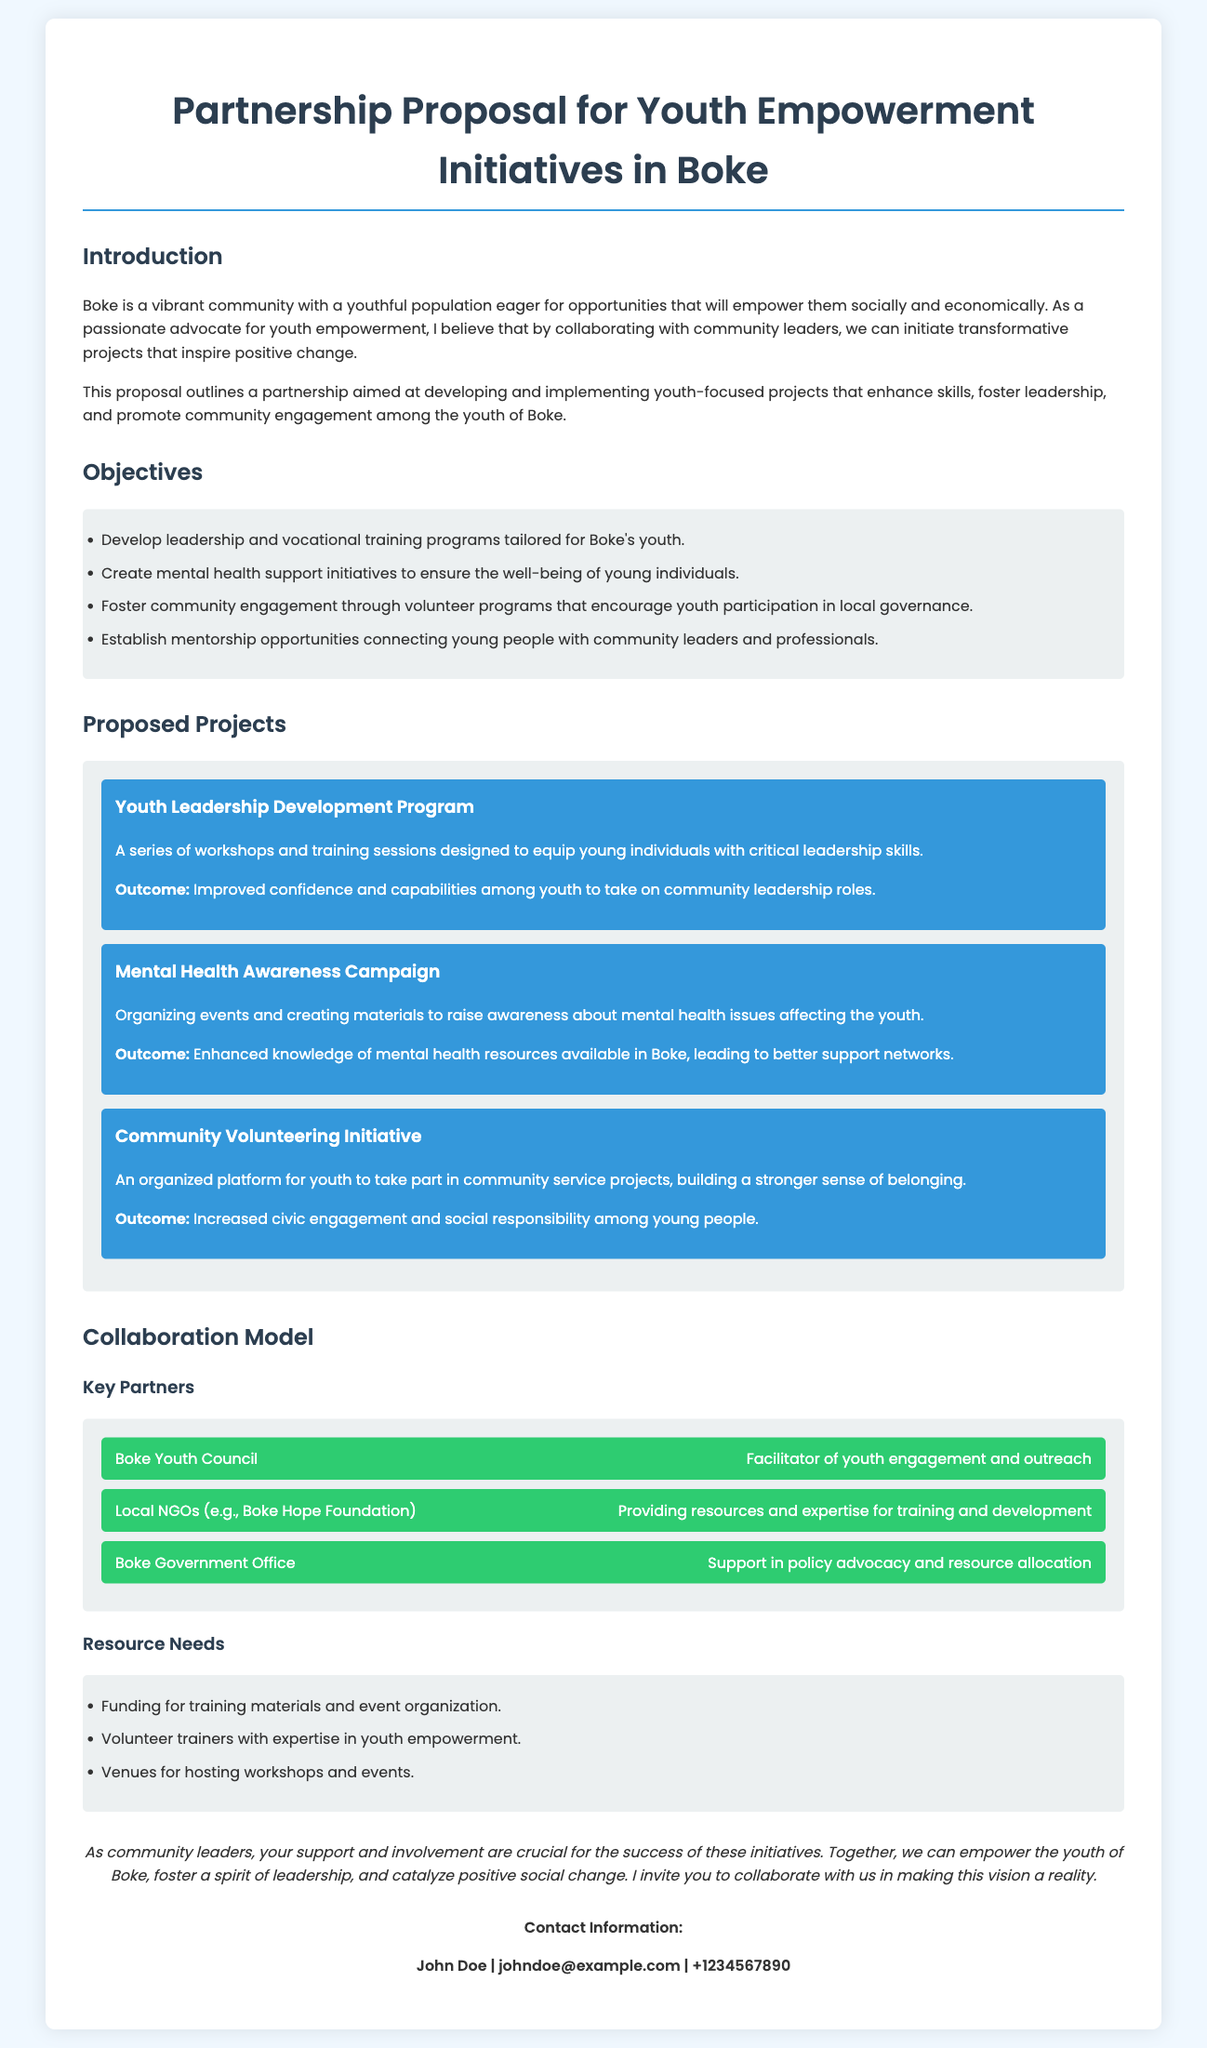What is the title of the proposal? The title of the proposal is outlined in the header of the document.
Answer: Partnership Proposal for Youth Empowerment Initiatives in Boke Who is the contact person mentioned in the document? The contact person is specified at the end of the document.
Answer: John Doe What is one of the key objectives of the proposal? Objectives can be found in the dedicated section detailing goals for youth empowerment.
Answer: Develop leadership and vocational training programs tailored for Boke's youth How many proposed projects are listed in the document? The specific number of proposed projects is noted in the corresponding section.
Answer: Three What organization is mentioned as a key partner for facilitating youth engagement? The name of the key partner is provided under the collaboration model.
Answer: Boke Youth Council What type of campaign is proposed to raise awareness about mental health? The type of campaign is specified in the proposed projects section.
Answer: Mental Health Awareness Campaign What is one of the resource needs identified in the proposal? Resource needs are listed in a specific section of the document.
Answer: Funding for training materials and event organization What is the expected outcome of the Community Volunteering Initiative? The expected outcome is described within the project details.
Answer: Increased civic engagement and social responsibility among young people 